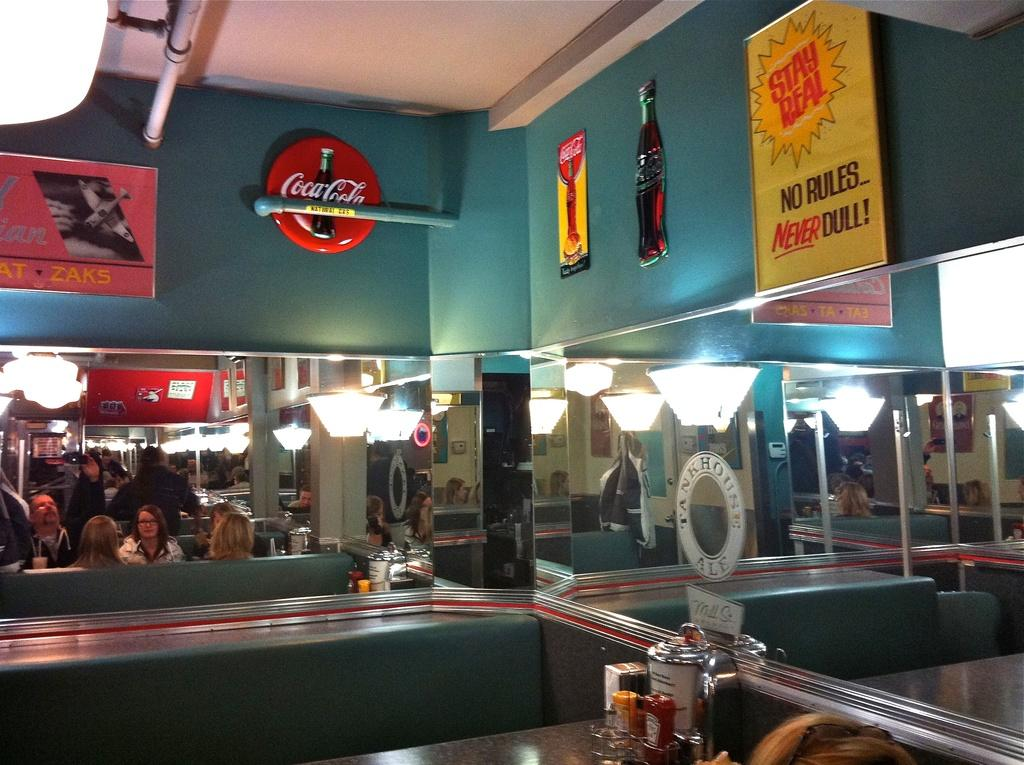What type of place is shown in the image? The image depicts a cafeteria. Are there any people present in the cafeteria? Yes, there are people in the cafeteria. What can be seen on the tables in the cafeteria? There are things on the table in the cafeteria. What is on the wall in the cafeteria? There are boards on the wall in the cafeteria. Can you see any writing on the print that is being stretched by the people in the image? There is no print or stretching activity depicted in the image; it shows a cafeteria with people and tables. 